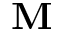<formula> <loc_0><loc_0><loc_500><loc_500>M</formula> 